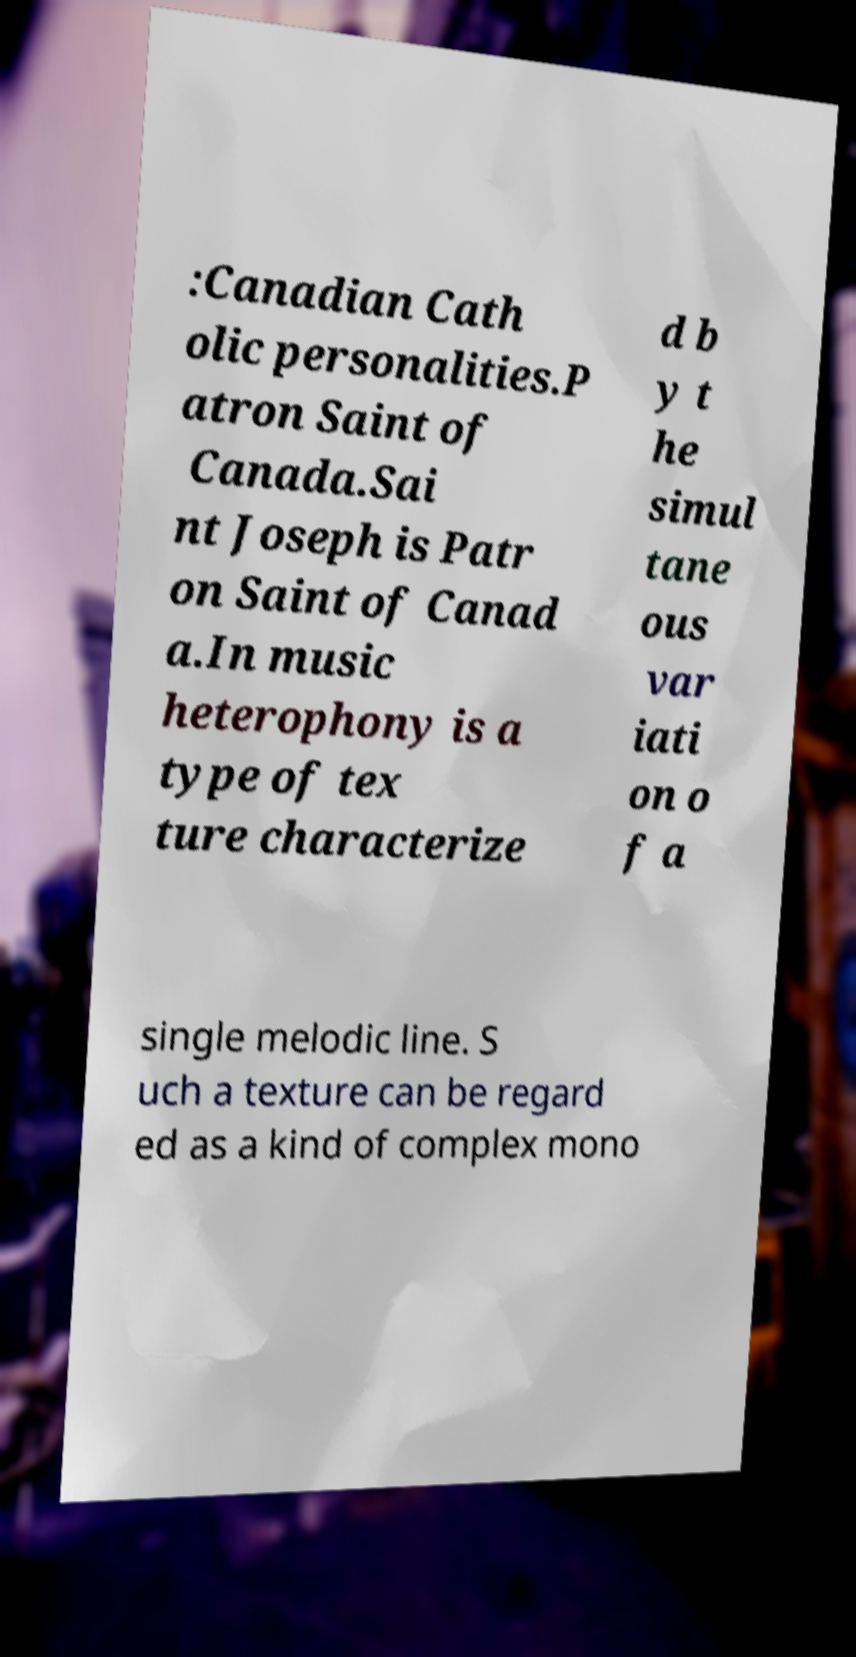Can you accurately transcribe the text from the provided image for me? :Canadian Cath olic personalities.P atron Saint of Canada.Sai nt Joseph is Patr on Saint of Canad a.In music heterophony is a type of tex ture characterize d b y t he simul tane ous var iati on o f a single melodic line. S uch a texture can be regard ed as a kind of complex mono 